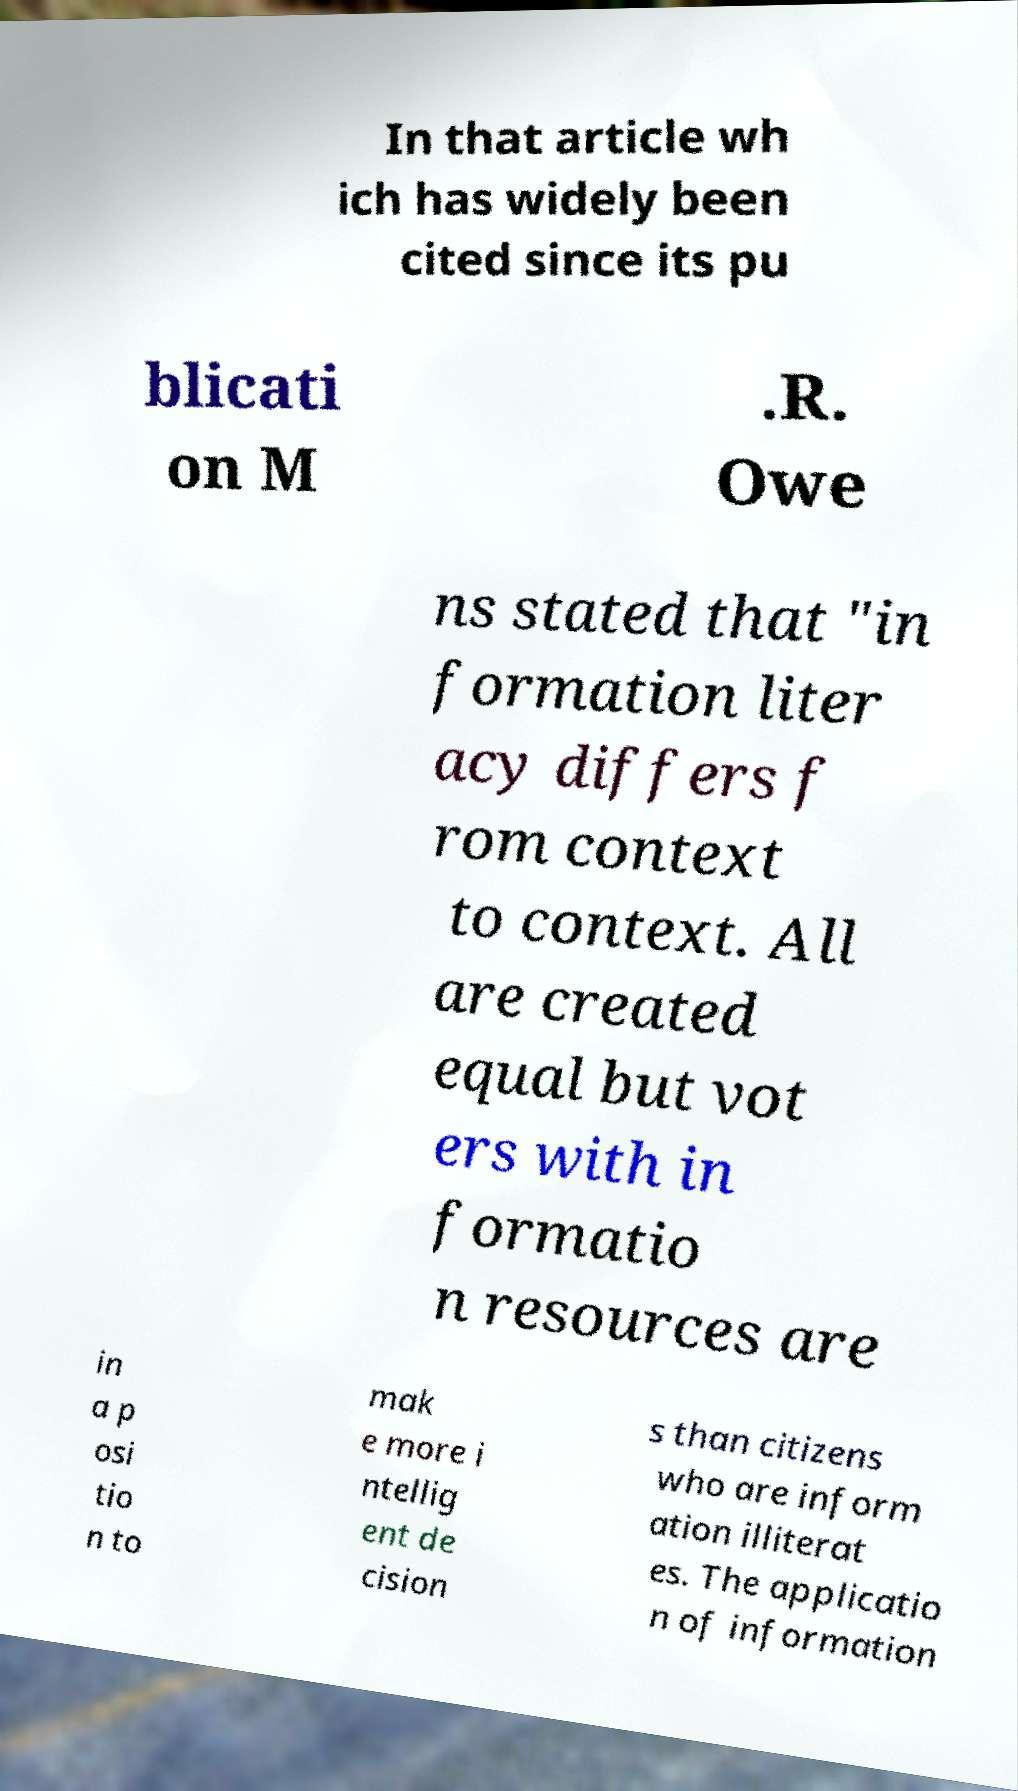There's text embedded in this image that I need extracted. Can you transcribe it verbatim? In that article wh ich has widely been cited since its pu blicati on M .R. Owe ns stated that "in formation liter acy differs f rom context to context. All are created equal but vot ers with in formatio n resources are in a p osi tio n to mak e more i ntellig ent de cision s than citizens who are inform ation illiterat es. The applicatio n of information 